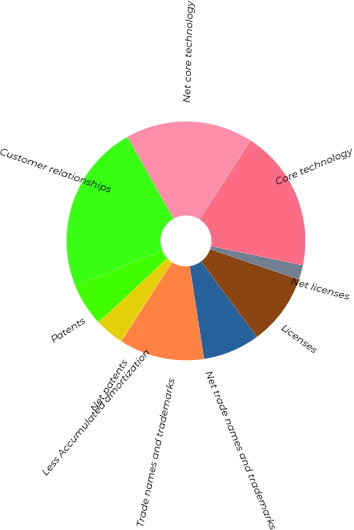Convert chart to OTSL. <chart><loc_0><loc_0><loc_500><loc_500><pie_chart><fcel>Patents<fcel>Less Accumulated amortization<fcel>Net patents<fcel>Trade names and trademarks<fcel>Net trade names and trademarks<fcel>Licenses<fcel>Net licenses<fcel>Core technology<fcel>Net core technology<fcel>Customer relationships<nl><fcel>5.8%<fcel>3.89%<fcel>0.07%<fcel>11.53%<fcel>7.71%<fcel>9.62%<fcel>1.98%<fcel>19.17%<fcel>17.26%<fcel>22.99%<nl></chart> 